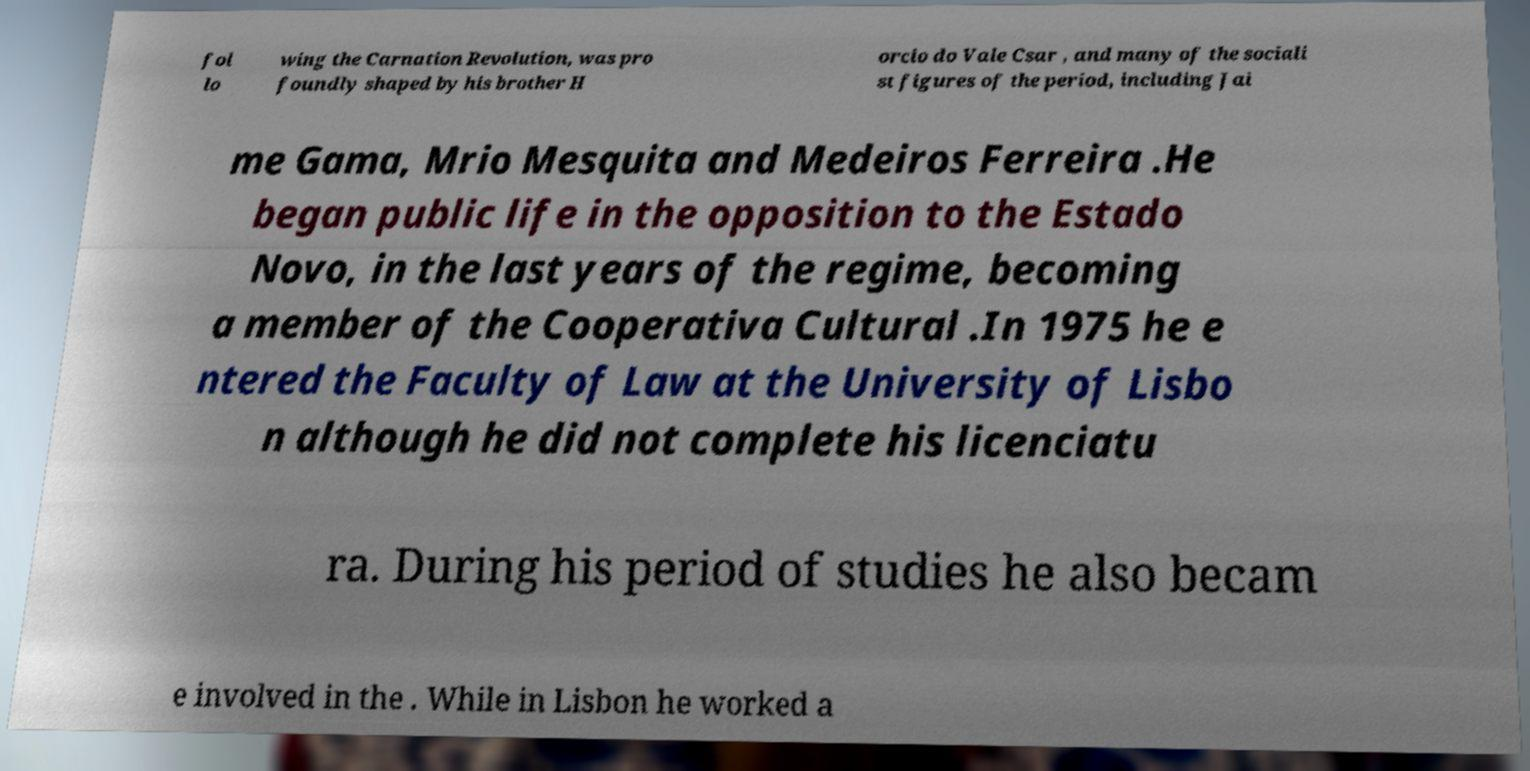I need the written content from this picture converted into text. Can you do that? fol lo wing the Carnation Revolution, was pro foundly shaped by his brother H orcio do Vale Csar , and many of the sociali st figures of the period, including Jai me Gama, Mrio Mesquita and Medeiros Ferreira .He began public life in the opposition to the Estado Novo, in the last years of the regime, becoming a member of the Cooperativa Cultural .In 1975 he e ntered the Faculty of Law at the University of Lisbo n although he did not complete his licenciatu ra. During his period of studies he also becam e involved in the . While in Lisbon he worked a 